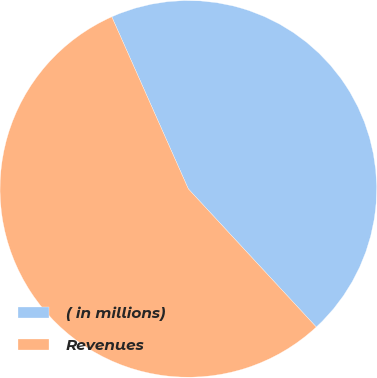<chart> <loc_0><loc_0><loc_500><loc_500><pie_chart><fcel>( in millions)<fcel>Revenues<nl><fcel>44.77%<fcel>55.23%<nl></chart> 